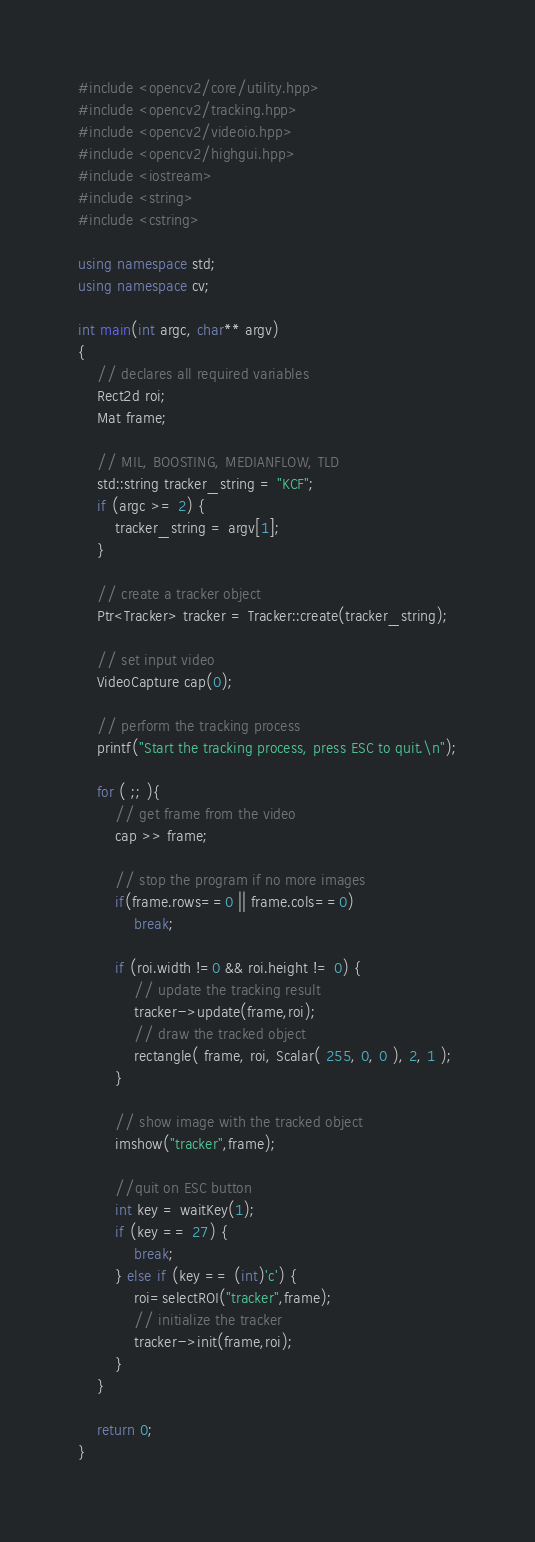Convert code to text. <code><loc_0><loc_0><loc_500><loc_500><_C++_>#include <opencv2/core/utility.hpp>
#include <opencv2/tracking.hpp>
#include <opencv2/videoio.hpp>
#include <opencv2/highgui.hpp>
#include <iostream>
#include <string>
#include <cstring>

using namespace std;
using namespace cv;

int main(int argc, char** argv)
{
    // declares all required variables
    Rect2d roi;
    Mat frame;

    // MIL, BOOSTING, MEDIANFLOW, TLD
    std::string tracker_string = "KCF";
    if (argc >= 2) {
        tracker_string = argv[1];
    }

    // create a tracker object
    Ptr<Tracker> tracker = Tracker::create(tracker_string);

    // set input video
    VideoCapture cap(0);

    // perform the tracking process
    printf("Start the tracking process, press ESC to quit.\n");

    for ( ;; ){
        // get frame from the video
        cap >> frame;

        // stop the program if no more images
        if(frame.rows==0 || frame.cols==0)
            break;

        if (roi.width !=0 && roi.height != 0) {
            // update the tracking result
            tracker->update(frame,roi);
            // draw the tracked object
            rectangle( frame, roi, Scalar( 255, 0, 0 ), 2, 1 );
        }

        // show image with the tracked object
        imshow("tracker",frame);

        //quit on ESC button
        int key = waitKey(1);
        if (key == 27) {
            break;
        } else if (key == (int)'c') {
            roi=selectROI("tracker",frame);
            // initialize the tracker
            tracker->init(frame,roi);
        }
    }

    return 0;
}

</code> 